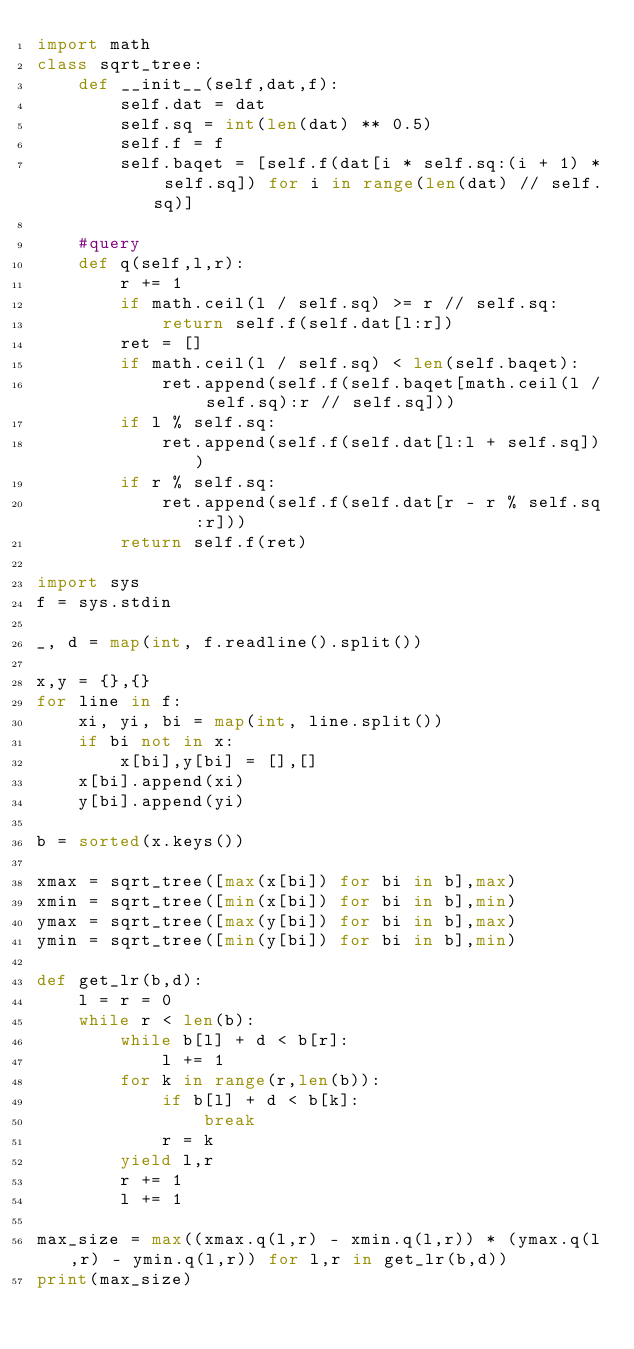Convert code to text. <code><loc_0><loc_0><loc_500><loc_500><_Python_>import math
class sqrt_tree:
    def __init__(self,dat,f):
        self.dat = dat
        self.sq = int(len(dat) ** 0.5)
        self.f = f
        self.baqet = [self.f(dat[i * self.sq:(i + 1) * self.sq]) for i in range(len(dat) // self.sq)]
    
    #query
    def q(self,l,r):
        r += 1
        if math.ceil(l / self.sq) >= r // self.sq:
            return self.f(self.dat[l:r])
        ret = []
        if math.ceil(l / self.sq) < len(self.baqet):
            ret.append(self.f(self.baqet[math.ceil(l / self.sq):r // self.sq]))
        if l % self.sq:
            ret.append(self.f(self.dat[l:l + self.sq]))
        if r % self.sq:
            ret.append(self.f(self.dat[r - r % self.sq:r]))
        return self.f(ret)

import sys
f = sys.stdin

_, d = map(int, f.readline().split())

x,y = {},{}
for line in f:
    xi, yi, bi = map(int, line.split())
    if bi not in x:
        x[bi],y[bi] = [],[]
    x[bi].append(xi)
    y[bi].append(yi)

b = sorted(x.keys())

xmax = sqrt_tree([max(x[bi]) for bi in b],max)
xmin = sqrt_tree([min(x[bi]) for bi in b],min)
ymax = sqrt_tree([max(y[bi]) for bi in b],max)
ymin = sqrt_tree([min(y[bi]) for bi in b],min)

def get_lr(b,d):
    l = r = 0
    while r < len(b):
        while b[l] + d < b[r]:
            l += 1
        for k in range(r,len(b)):
            if b[l] + d < b[k]:
                break
            r = k
        yield l,r
        r += 1
        l += 1
    
max_size = max((xmax.q(l,r) - xmin.q(l,r)) * (ymax.q(l,r) - ymin.q(l,r)) for l,r in get_lr(b,d))
print(max_size)</code> 